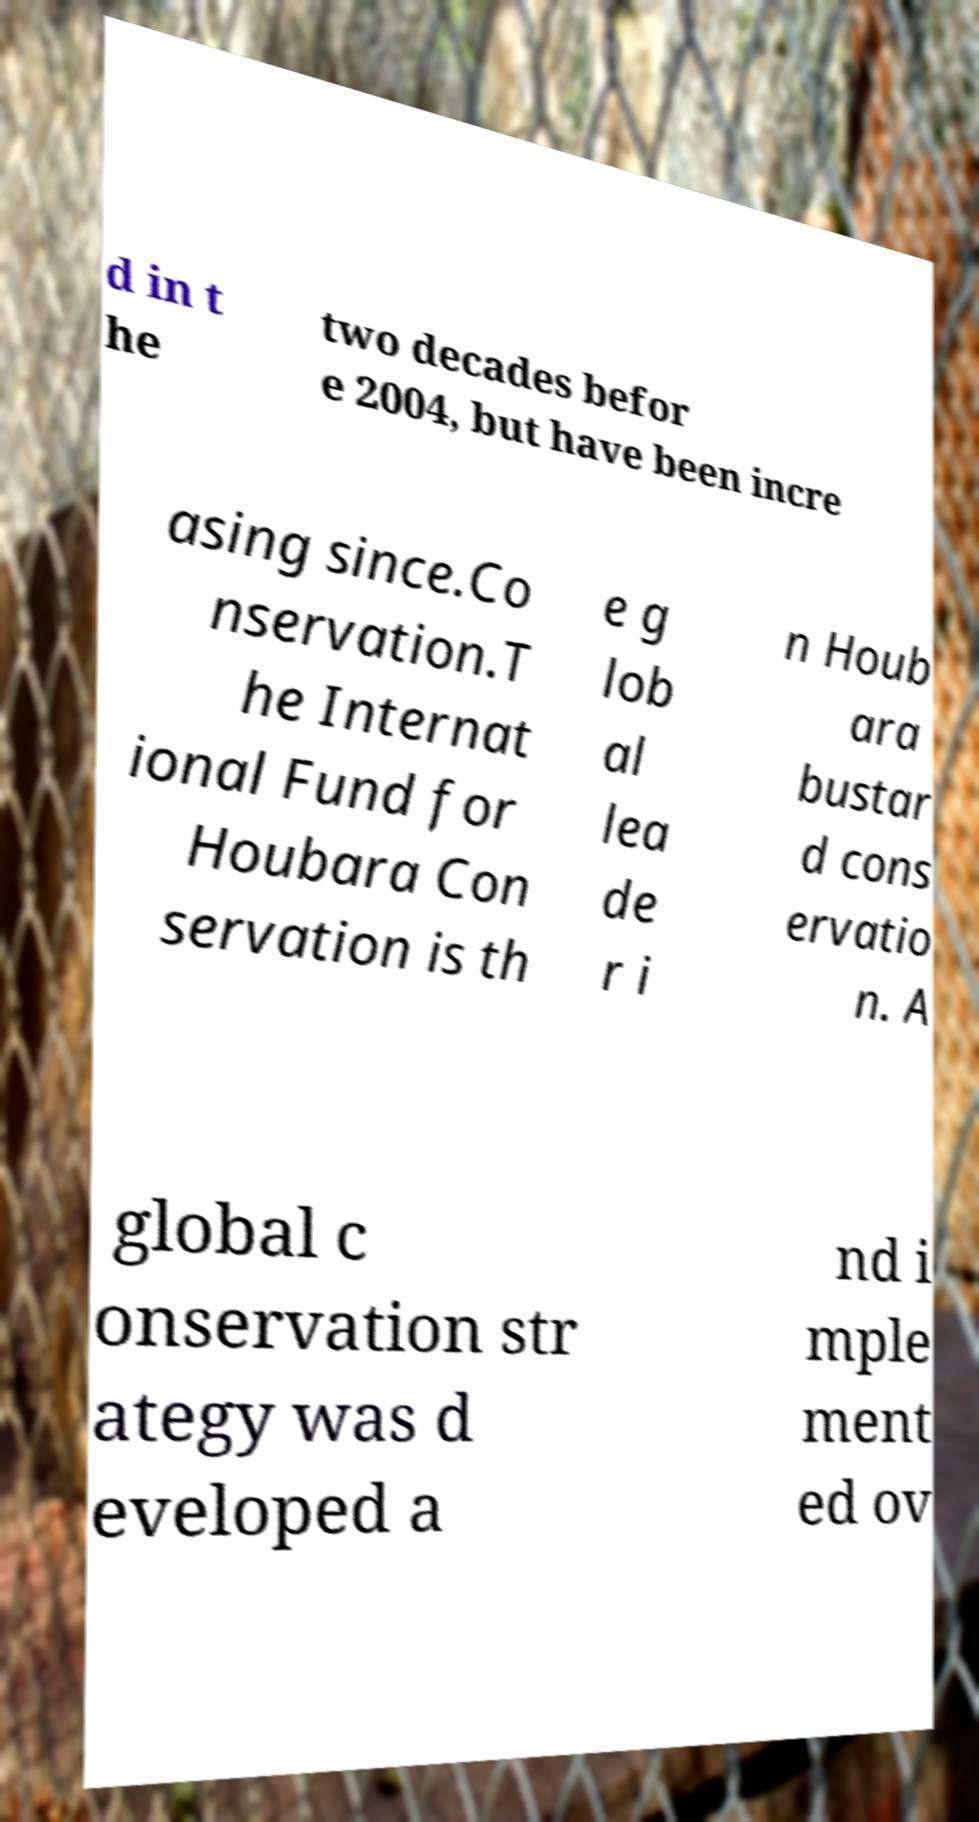Could you extract and type out the text from this image? d in t he two decades befor e 2004, but have been incre asing since.Co nservation.T he Internat ional Fund for Houbara Con servation is th e g lob al lea de r i n Houb ara bustar d cons ervatio n. A global c onservation str ategy was d eveloped a nd i mple ment ed ov 